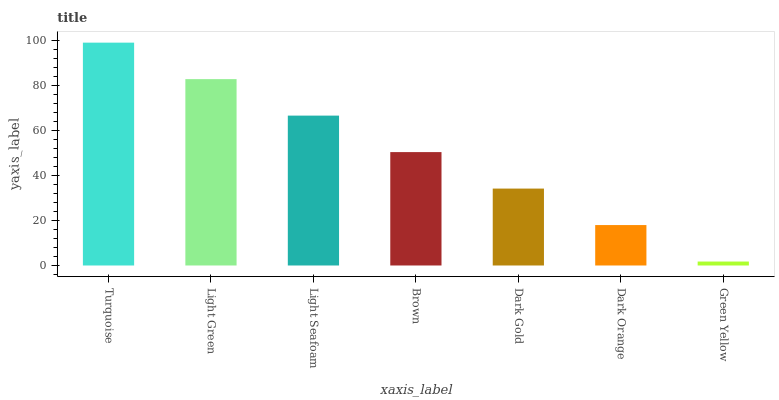Is Light Green the minimum?
Answer yes or no. No. Is Light Green the maximum?
Answer yes or no. No. Is Turquoise greater than Light Green?
Answer yes or no. Yes. Is Light Green less than Turquoise?
Answer yes or no. Yes. Is Light Green greater than Turquoise?
Answer yes or no. No. Is Turquoise less than Light Green?
Answer yes or no. No. Is Brown the high median?
Answer yes or no. Yes. Is Brown the low median?
Answer yes or no. Yes. Is Light Green the high median?
Answer yes or no. No. Is Turquoise the low median?
Answer yes or no. No. 